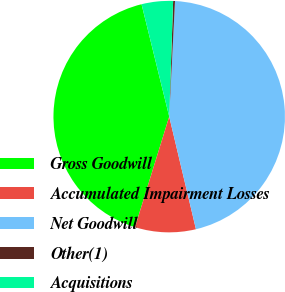Convert chart. <chart><loc_0><loc_0><loc_500><loc_500><pie_chart><fcel>Gross Goodwill<fcel>Accumulated Impairment Losses<fcel>Net Goodwill<fcel>Other(1)<fcel>Acquisitions<nl><fcel>41.38%<fcel>8.49%<fcel>45.49%<fcel>0.26%<fcel>4.38%<nl></chart> 